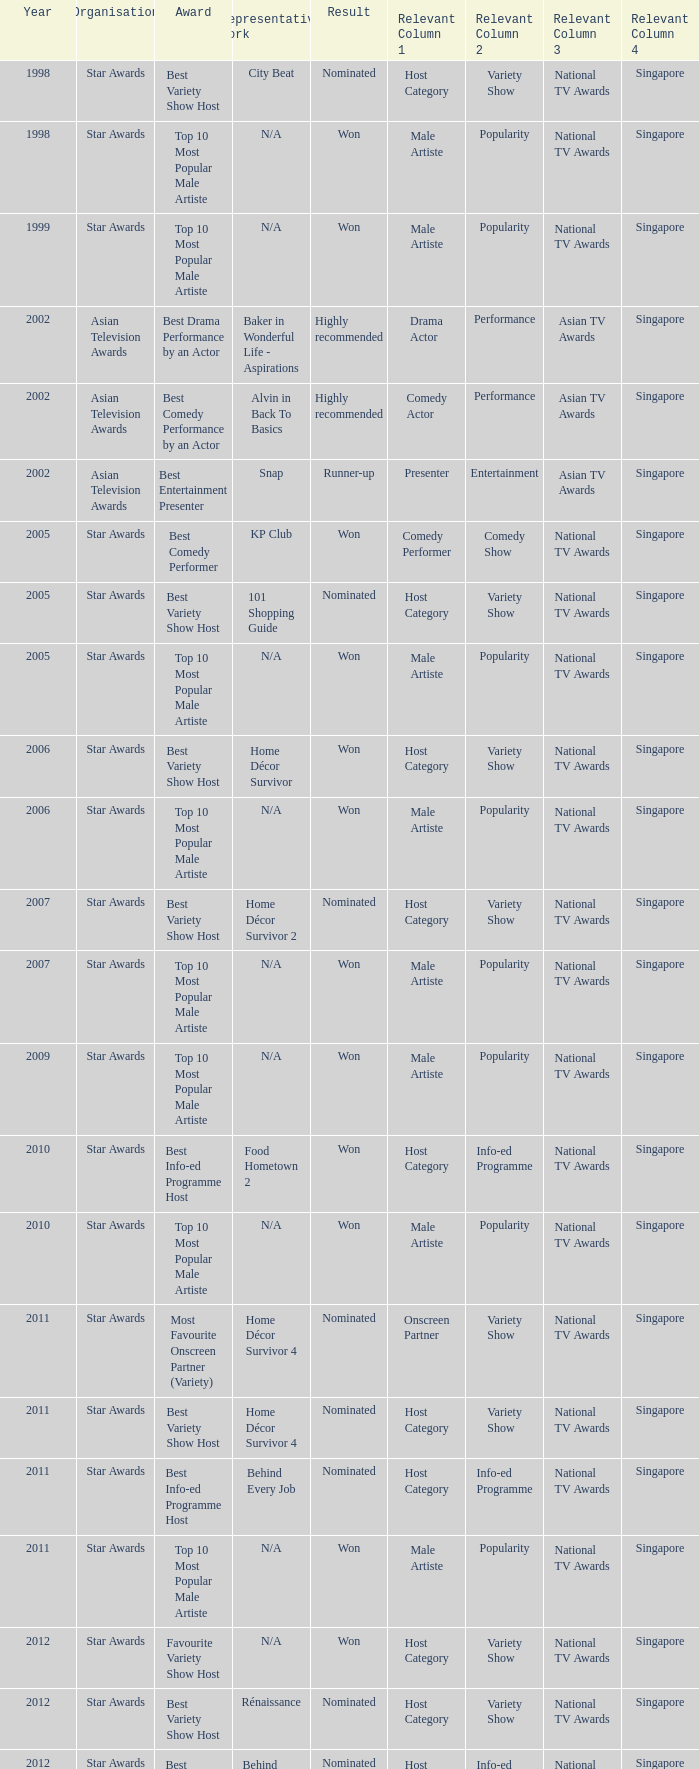What is the name of the Representative Work in a year later than 2005 with a Result of nominated, and an Award of best variety show host? Home Décor Survivor 2, Home Décor Survivor 4, Rénaissance, Jobs Around The World. 